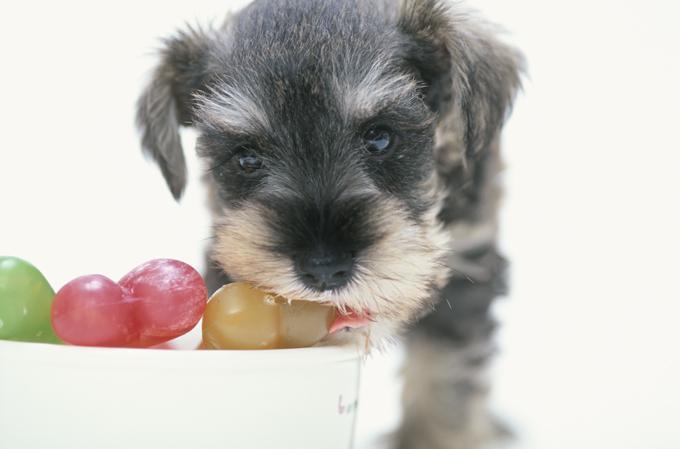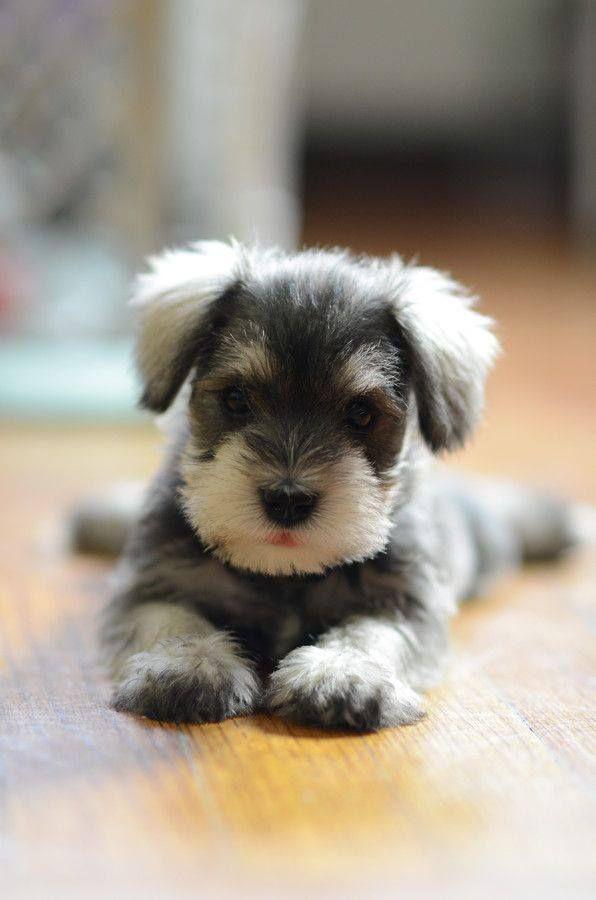The first image is the image on the left, the second image is the image on the right. For the images shown, is this caption "A dog is chewing on something in one of the photos." true? Answer yes or no. Yes. The first image is the image on the left, the second image is the image on the right. Assess this claim about the two images: "In one of the images there is a dog chewing a dog bone.". Correct or not? Answer yes or no. Yes. 